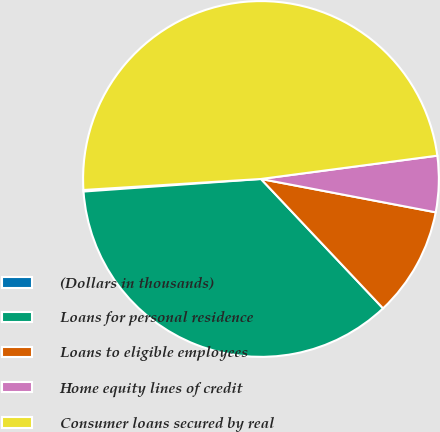Convert chart to OTSL. <chart><loc_0><loc_0><loc_500><loc_500><pie_chart><fcel>(Dollars in thousands)<fcel>Loans for personal residence<fcel>Loans to eligible employees<fcel>Home equity lines of credit<fcel>Consumer loans secured by real<nl><fcel>0.14%<fcel>35.91%<fcel>9.96%<fcel>5.09%<fcel>48.89%<nl></chart> 